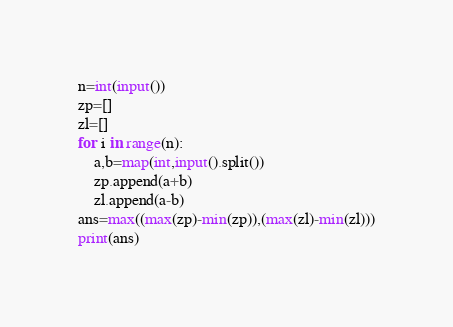<code> <loc_0><loc_0><loc_500><loc_500><_Python_>n=int(input())
zp=[]
zl=[]
for i in range(n):
    a,b=map(int,input().split())
    zp.append(a+b)
    zl.append(a-b)
ans=max((max(zp)-min(zp)),(max(zl)-min(zl)))
print(ans)</code> 